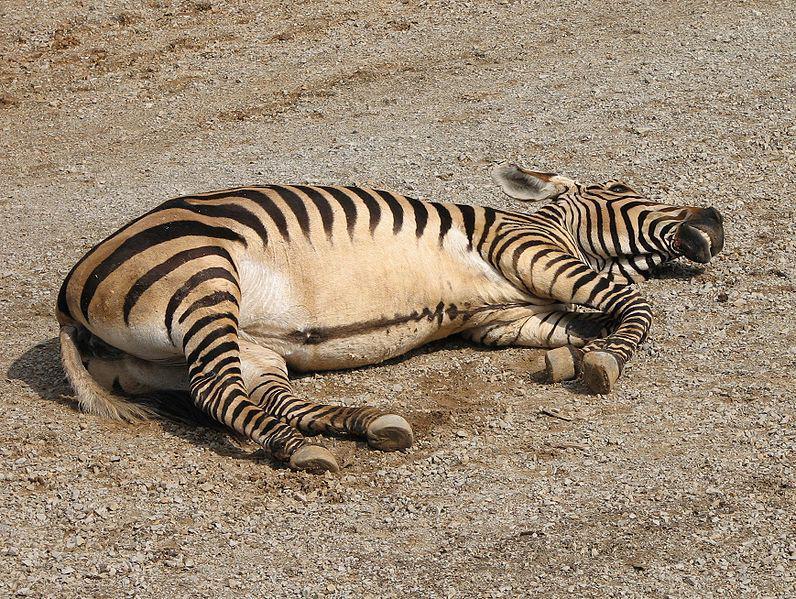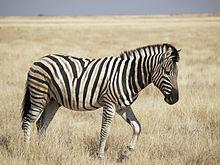The first image is the image on the left, the second image is the image on the right. Analyze the images presented: Is the assertion "There are two zebras" valid? Answer yes or no. Yes. The first image is the image on the left, the second image is the image on the right. For the images displayed, is the sentence "One image includes a zebra lying flat on its side with its head also flat on the brown ground." factually correct? Answer yes or no. Yes. 